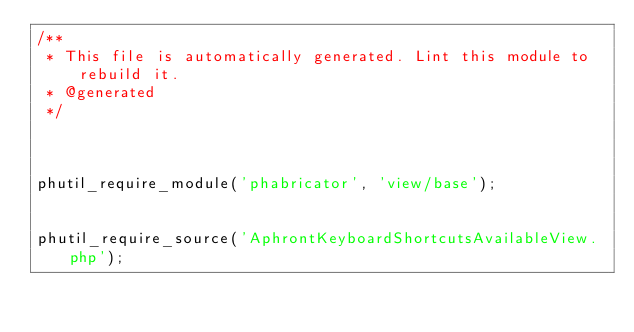<code> <loc_0><loc_0><loc_500><loc_500><_PHP_>/**
 * This file is automatically generated. Lint this module to rebuild it.
 * @generated
 */



phutil_require_module('phabricator', 'view/base');


phutil_require_source('AphrontKeyboardShortcutsAvailableView.php');
</code> 